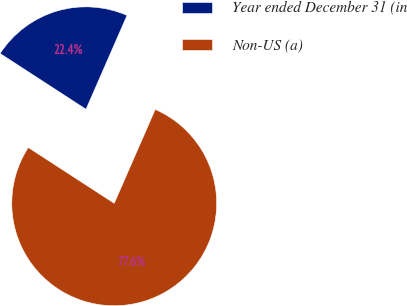<chart> <loc_0><loc_0><loc_500><loc_500><pie_chart><fcel>Year ended December 31 (in<fcel>Non-US (a)<nl><fcel>22.39%<fcel>77.61%<nl></chart> 